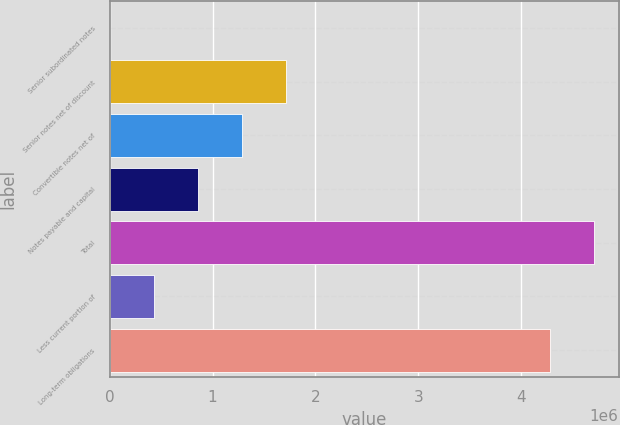<chart> <loc_0><loc_0><loc_500><loc_500><bar_chart><fcel>Senior subordinated notes<fcel>Senior notes net of discount<fcel>Convertible notes net of<fcel>Notes payable and capital<fcel>Total<fcel>Less current portion of<fcel>Long-term obligations<nl><fcel>288<fcel>1.71429e+06<fcel>1.28579e+06<fcel>857287<fcel>4.71197e+06<fcel>428788<fcel>4.28347e+06<nl></chart> 